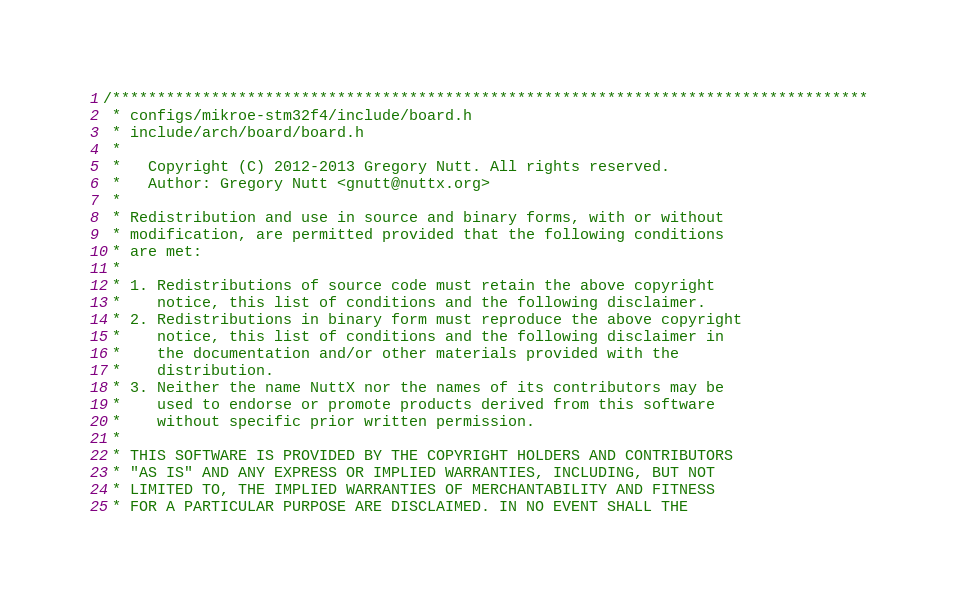<code> <loc_0><loc_0><loc_500><loc_500><_C_>/************************************************************************************
 * configs/mikroe-stm32f4/include/board.h
 * include/arch/board/board.h
 *
 *   Copyright (C) 2012-2013 Gregory Nutt. All rights reserved.
 *   Author: Gregory Nutt <gnutt@nuttx.org>
 *
 * Redistribution and use in source and binary forms, with or without
 * modification, are permitted provided that the following conditions
 * are met:
 *
 * 1. Redistributions of source code must retain the above copyright
 *    notice, this list of conditions and the following disclaimer.
 * 2. Redistributions in binary form must reproduce the above copyright
 *    notice, this list of conditions and the following disclaimer in
 *    the documentation and/or other materials provided with the
 *    distribution.
 * 3. Neither the name NuttX nor the names of its contributors may be
 *    used to endorse or promote products derived from this software
 *    without specific prior written permission.
 *
 * THIS SOFTWARE IS PROVIDED BY THE COPYRIGHT HOLDERS AND CONTRIBUTORS
 * "AS IS" AND ANY EXPRESS OR IMPLIED WARRANTIES, INCLUDING, BUT NOT
 * LIMITED TO, THE IMPLIED WARRANTIES OF MERCHANTABILITY AND FITNESS
 * FOR A PARTICULAR PURPOSE ARE DISCLAIMED. IN NO EVENT SHALL THE</code> 